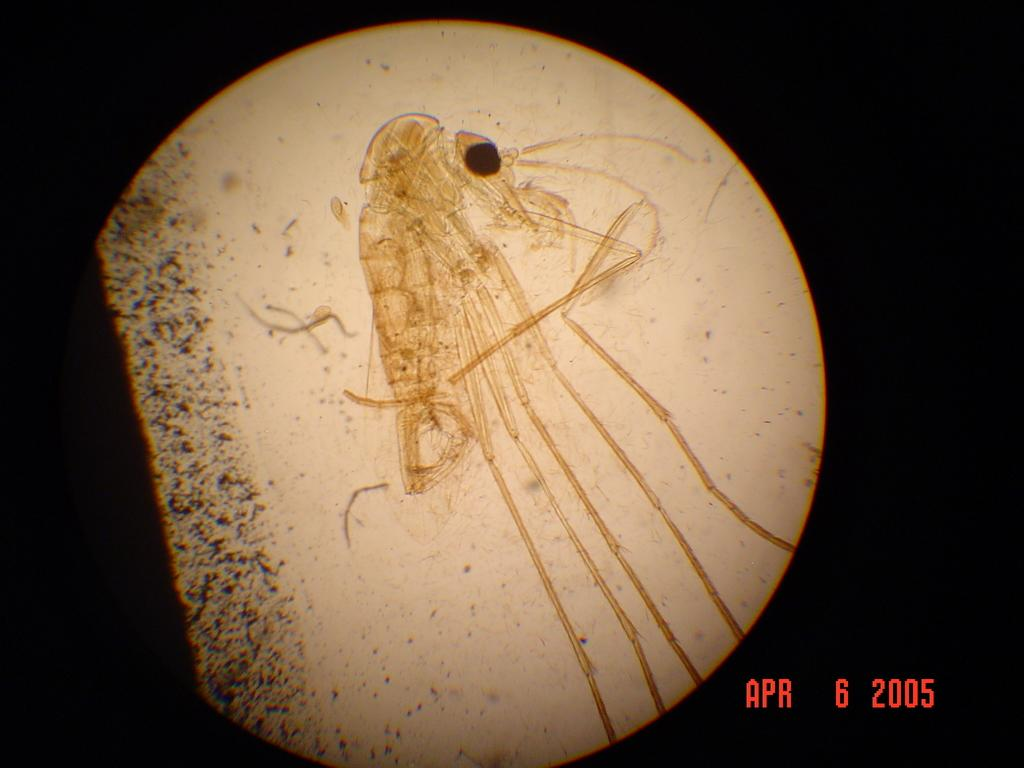What type of artwork is depicted in the image? The image appears to be a painting. What is one of the subjects in the painting? There is an insect in the painting. How would you describe the overall color scheme of the painting? The background of the painting is dark. How many dogs are visible in the painting? There are no dogs present in the painting; it features an insect and a dark background. What is the ray's role in the painting? There is no ray present in the painting; it only contains an insect and a dark background. 